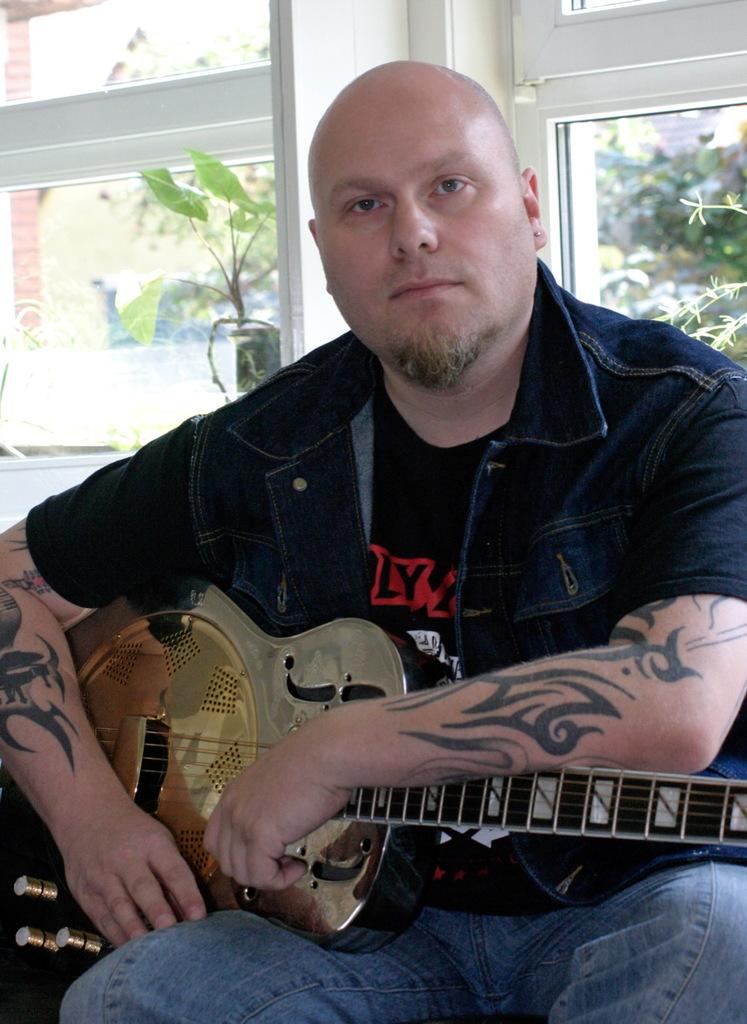What is the person in the image doing? The person is sitting in the image and holding a guitar. What can be seen in the background of the image? There is a plant, a tree, and a window in the background of the image. What type of suit is the person wearing in the image? There is no suit visible in the image; the person is holding a guitar. What idea does the plant in the background represent in the image? The plant in the background does not represent any specific idea; it is simply a part of the background. 